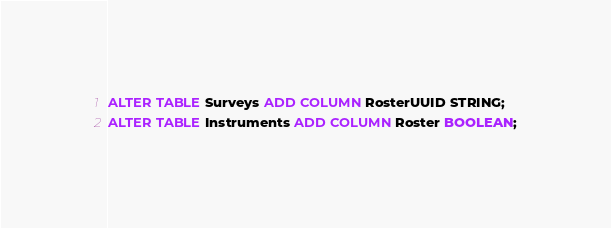Convert code to text. <code><loc_0><loc_0><loc_500><loc_500><_SQL_>ALTER TABLE Surveys ADD COLUMN RosterUUID STRING;
ALTER TABLE Instruments ADD COLUMN Roster BOOLEAN;</code> 